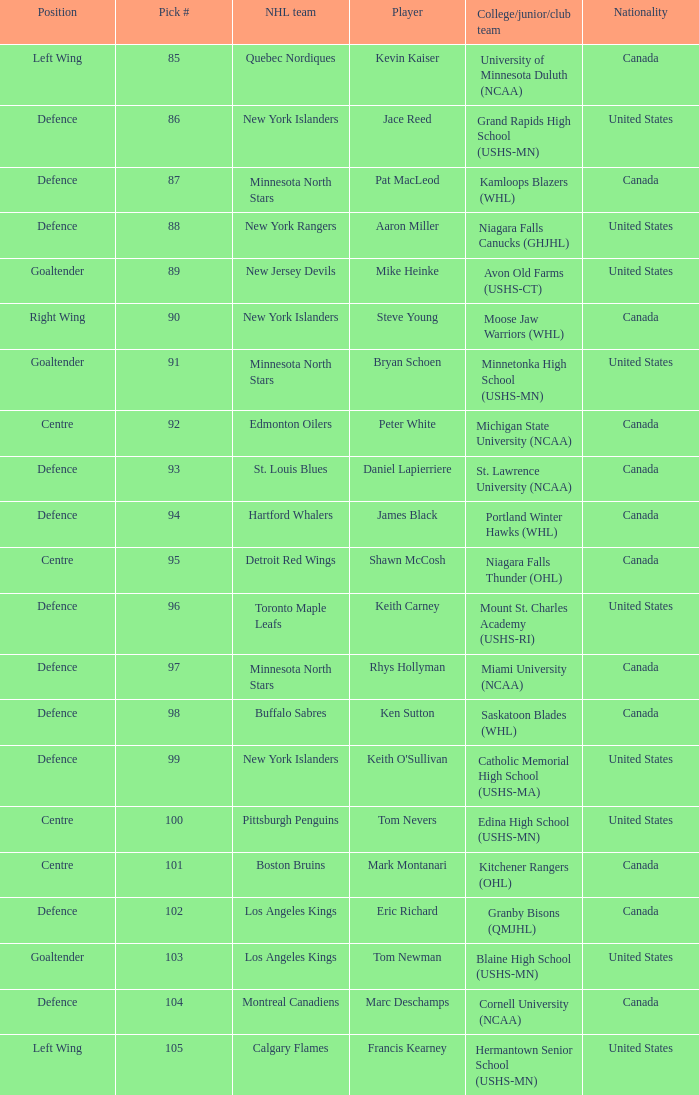What player attended avon old farms (ushs-ct)? Mike Heinke. 